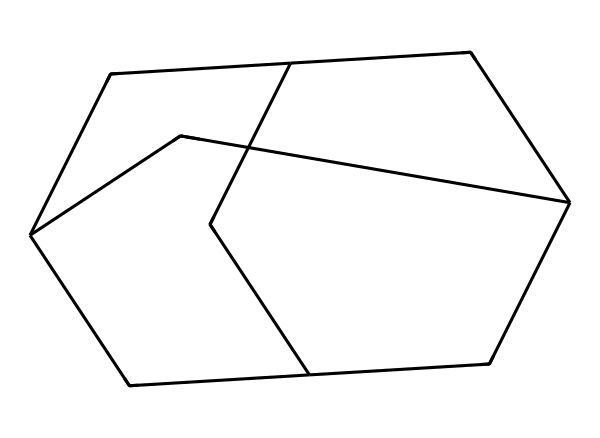What is the total number of carbon atoms in adamantane? The provided SMILES representation directly encodes the structure of adamantane, which consists of 10 carbon atoms arranged in a specific shape. By counting the carbon symbols in the SMILES, we find there are 10.
Answer: 10 How many rings does adamantane contain? The structure of adamantane can be analyzed through its SMILES, which shows interconnected carbon atoms forming a three-dimensional shape. Adamantane has a characteristic cage-like structure that includes four interconnected carbon rings.
Answer: 4 What type of compound is adamantane classified as? Adamantane is recognized as a cage compound. The structure features a highly symmetrical arrangement of carbon atoms, which is typical for such compounds, especially in the context of its use in diamond-like polishes.
Answer: cage compound What is the degree of saturation of adamantane? The degree of saturation indicates the number of rings and/or double bonds in a compound. Adamantane is fully saturated with no double bonds and consists only of single bonds in its ring structure. This indicates it is completely saturated.
Answer: fully saturated What type of bonds are present in the adamantane structure? By examining the connections in the SMILES representation, one can identify that all connections between carbon atoms in adamantane are single bonds, typical for saturated hydrocarbons.
Answer: single bonds How does the branching in adamantane's structure impact its properties? The branching in the adamantane structure contributes to its unique physical properties by preventing tight packing, influencing its melting point and stability. This branching promotes a compact yet stable form.
Answer: unique properties 